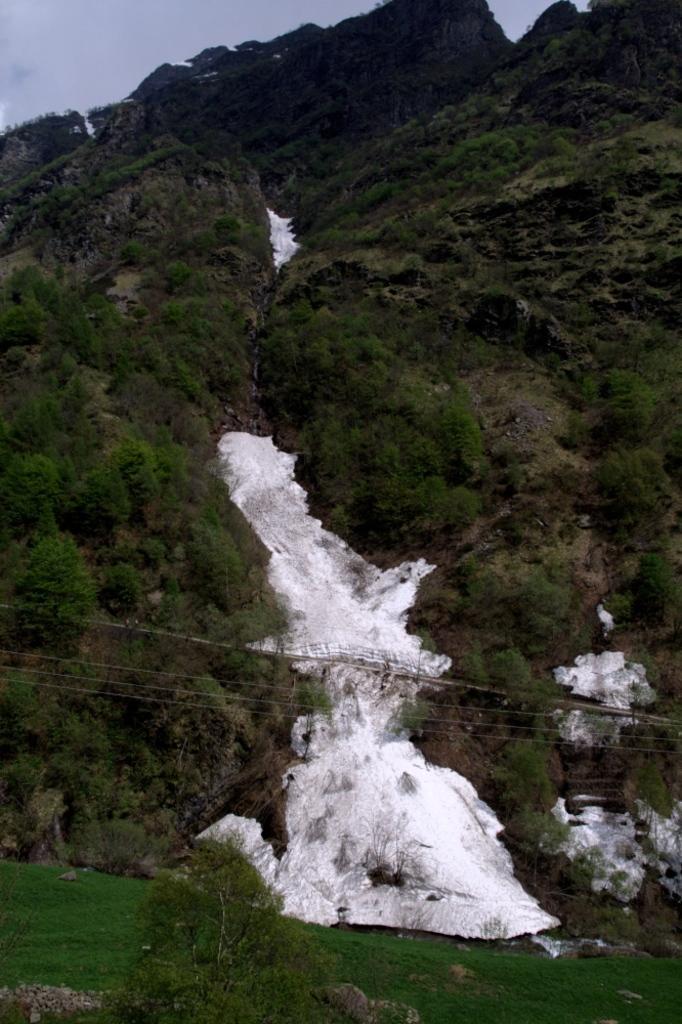Could you give a brief overview of what you see in this image? This picture shows few trees and we see snow and grass on the ground and a cloudy sky. 